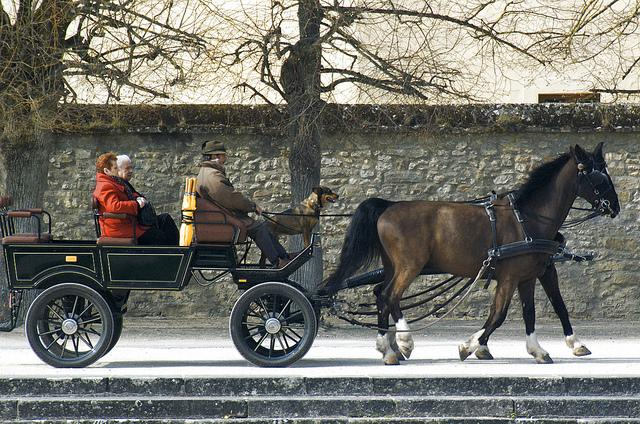In which season are the people traveling on the black horse drawn coach? Please explain your reasoning. winter. People are in a carriage and snow is on the ground. snow is around in the winter. 